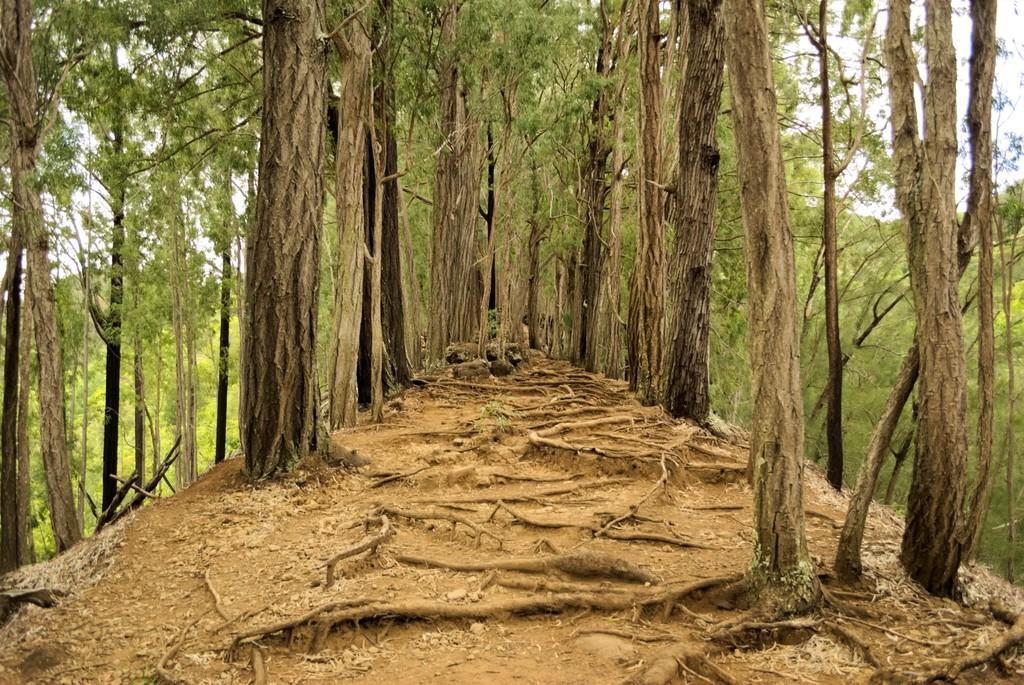In one or two sentences, can you explain what this image depicts? We can see trees and roots. In the background we can see sky. 